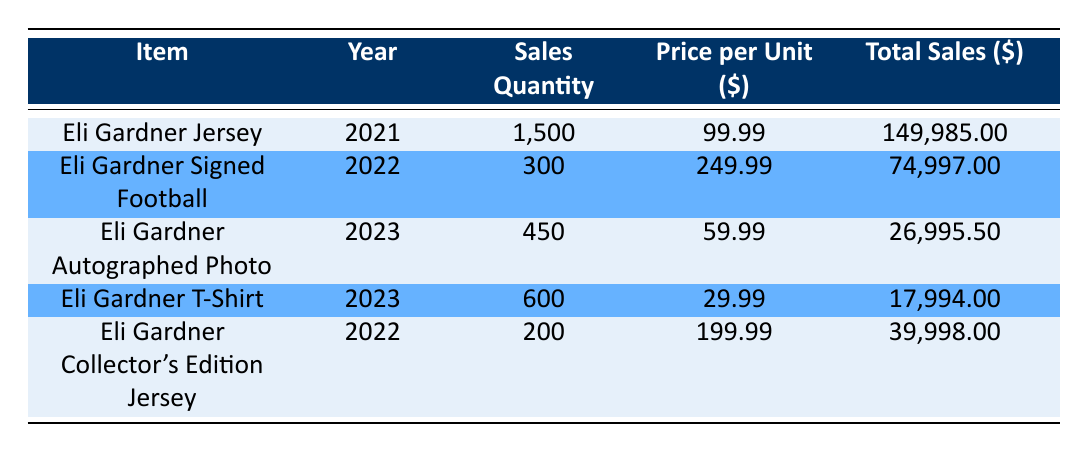What is the total sales amount for the Eli Gardner Jersey? The total sales amount for the Eli Gardner Jersey is clearly listed in the table under the "Total Sales" column for the year 2021, which shows a value of 149,985.
Answer: 149,985 How many Eli Gardner Signed Footballs were sold in 2022? The sales quantity of Eli Gardner Signed Footballs is directly indicated in the "Sales Quantity" column for the year 2022, which is 300.
Answer: 300 What was the price per unit for the Eli Gardner Collector's Edition Jersey? The price per unit for the Eli Gardner Collector's Edition Jersey can be found in the corresponding row under the "Price per Unit" column, which states 199.99.
Answer: 199.99 What is the total sales for all merchandise items in 2023? To find the total sales for all items in 2023, we look at the total sales for each item sold that year: 26,995.50 (Autographed Photo) + 17,994 (T-Shirt) = 44,989.50.
Answer: 44,989.50 Did the sales of Eli Gardner's memorabilia increase from 2021 to 2022? To determine this, we compare the total sales amounts: 2021 (149,985) for the Jersey and 2022 (74,997 + 39,998) for the Signed Football and Collector's Edition Jersey, which adds up to 114,995. Therefore, sales decreased from 2021 to 2022.
Answer: No What is the average price per unit of items sold in 2022? The items sold in 2022 include the Signed Football at 249.99 and the Collector's Edition Jersey at 199.99. To find the average, we compute (249.99 + 199.99) / 2 = 224.99.
Answer: 224.99 Which item had the highest sales quantity? Reviewing the "Sales Quantity" column, we find that the Eli Gardner Jersey had 1,500 units sold, which is higher than all other items.
Answer: Eli Gardner Jersey How much more was earned from the Eli Gardner Signed Football compared to the Eli Gardner T-Shirt in 2023? The total sales for the Signed Football in 2022 is 74,997 and for the T-Shirt in 2023 is 17,994. The difference is 74,997 - 17,994 = 56,003.
Answer: 56,003 What percentage of total sales in 2022 came from the Eli Gardner Collector's Edition Jersey? In 2022, total sales were 74,997 (Signed Football) + 39,998 (Collector's Edition Jersey) = 114,995. The sales from the Collector's Edition Jersey were 39,998. To find the percentage: (39,998 / 114,995) * 100 = 34.8%.
Answer: 34.8% 